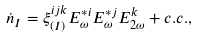Convert formula to latex. <formula><loc_0><loc_0><loc_500><loc_500>\dot { n } _ { I } = \xi _ { \left ( I \right ) } ^ { i j k } E _ { \omega } ^ { * i } E _ { \omega } ^ { * j } E _ { 2 \omega } ^ { k } + c . c . ,</formula> 